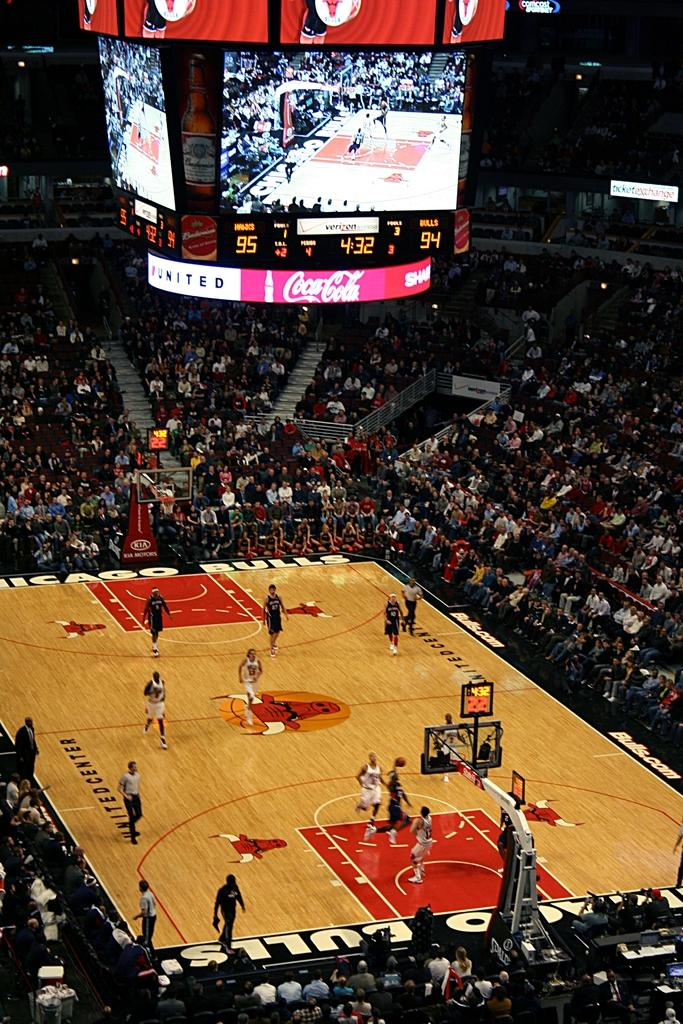<image>
Describe the image concisely. A packed basketball game is underway sponsored by Coca-Cola 